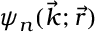Convert formula to latex. <formula><loc_0><loc_0><loc_500><loc_500>\psi _ { n } ( \vec { k } ; \vec { r } )</formula> 